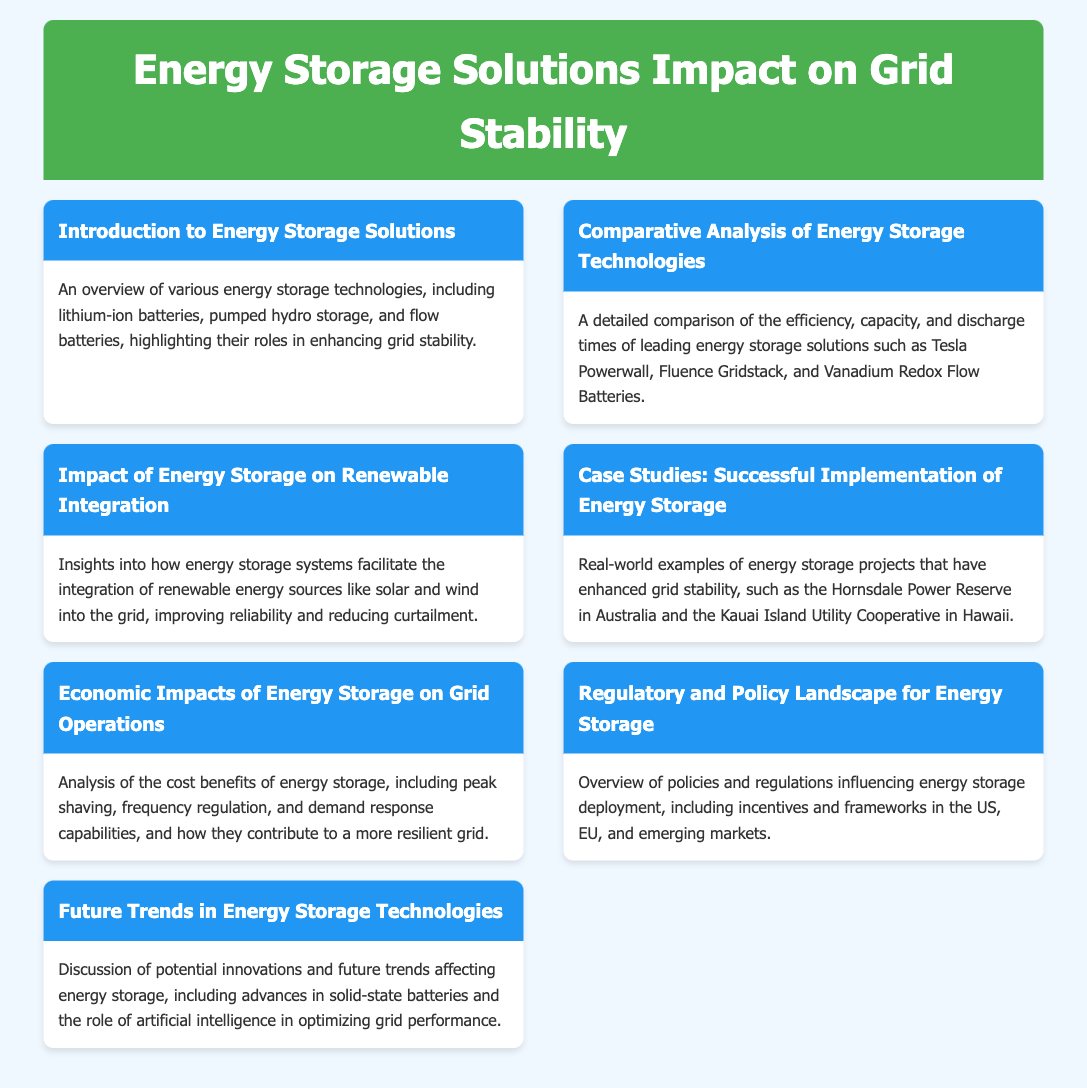What sectors do energy storage technologies support? The document mentions that energy storage technologies play a role in enhancing grid stability, which benefits various sectors including renewable energy integration.
Answer: Renewable energy integration Which energy storage technology is a significant example in the document? The document references several technologies, but Tesla Powerwall is highlighted as a leading energy storage solution.
Answer: Tesla Powerwall How does energy storage affect grid reliability? Energy storage systems improve reliability by facilitating the integration of renewable energy sources and reducing curtailment.
Answer: Improves reliability What is a case study mentioned in the document? The document lists real-world examples of successful energy storage projects, specifically mentioning the Hornsdale Power Reserve.
Answer: Hornsdale Power Reserve What type of analysis is provided regarding energy storage's economic impacts? The document includes an analysis of cost benefits related to energy storage operations on grid performance and resilience.
Answer: Cost benefits What future technology trend is discussed in the document? The document discusses potential innovations including advances in solid-state batteries for energy storage.
Answer: Solid-state batteries How are policies described in the document related to energy storage? The document provides an overview of the regulatory and policy landscape influencing energy storage deployment, including incentives and frameworks.
Answer: Regulatory landscape What critical aspect of grid operations does energy storage contribute to? The cost benefits analysis includes specific contributions like peak shaving and frequency regulation from energy storage systems.
Answer: Peak shaving 